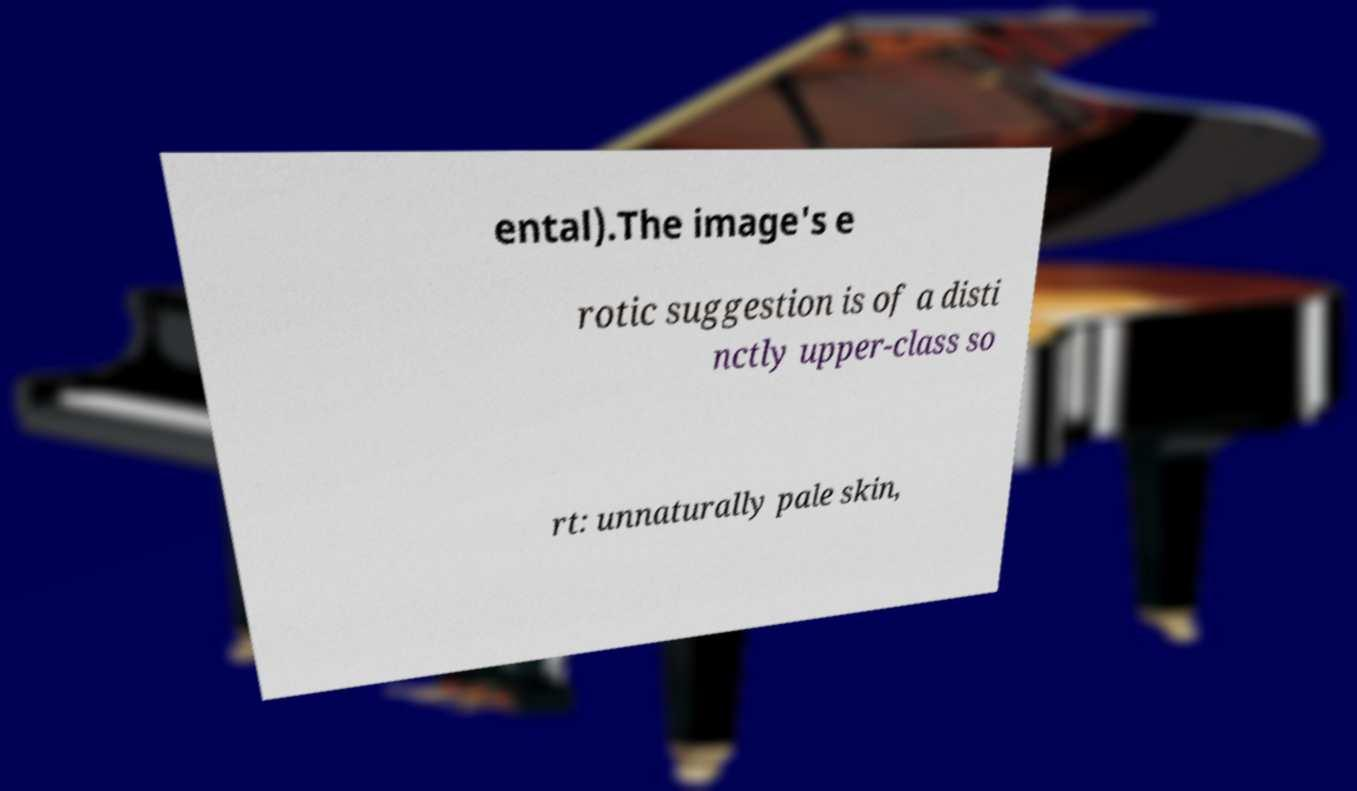Please read and relay the text visible in this image. What does it say? ental).The image's e rotic suggestion is of a disti nctly upper-class so rt: unnaturally pale skin, 